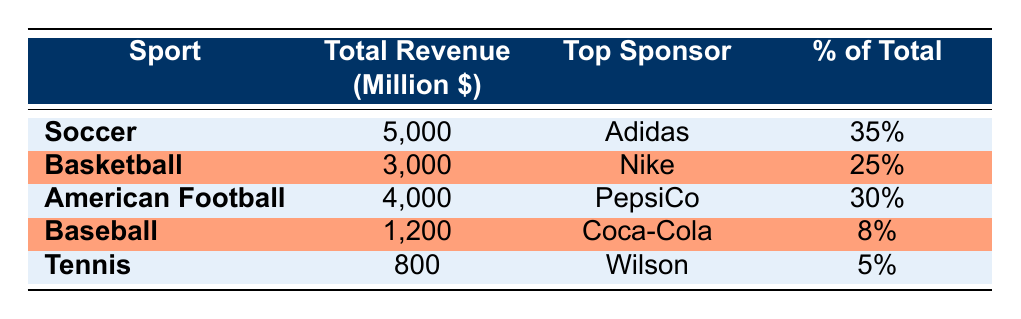What sport had the highest sponsorship revenue in 2022? The sport with the highest total revenue is Soccer, which had a total revenue of 5,000 million dollars. This can be found in the table as it lists Soccer at the top with the corresponding revenue.
Answer: Soccer Who was the top sponsor for American Football? The table shows that the top sponsor for American Football is PepsiCo. It lists PepsiCo in the relevant row under the "Top Sponsor" column for American Football.
Answer: PepsiCo What is the percentage of total sponsorship revenue represented by Baseball? The table states that Baseball has a percentage of total sponsorship revenue equal to 8%. This is found directly in the row corresponding to Baseball under the "% of Total" column.
Answer: 8% What is the total sponsorship revenue from Soccer and American Football combined? To find the combined total, we add the total revenue of both sports: 5,000 million (Soccer) + 4,000 million (American Football) = 9,000 million dollars. This calculation uses the total revenue figures from their respective rows.
Answer: 9,000 million Is it true that Tennis has a higher revenue than Baseball? No, it is not true. The table shows that Tennis has a revenue of 800 million while Baseball has a revenue of 1,200 million, making Baseball's revenue greater than Tennis.
Answer: No What sport has the lowest sponsorship revenue? According to the table, Tennis has the lowest total revenue at 800 million dollars. This can be determined by checking the total revenue figures listed for each sport and identifying the smallest value.
Answer: Tennis What percentage of the total sponsorship revenue comes from Basketball? The table indicates that Basketball represents 25% of the total sponsorship revenue. This information is specified in the row corresponding to Basketball under the "% of Total" column.
Answer: 25% If the total sponsorship revenue for all sports is 14,000 million, how much revenue was generated by all sports except for Soccer? The total revenue excluding Soccer is calculated by subtracting Soccer's revenue from the total: 14,000 million - 5,000 million = 9,000 million dollars. This requires combining the information of total revenue and the specific revenue from Soccer.
Answer: 9,000 million 